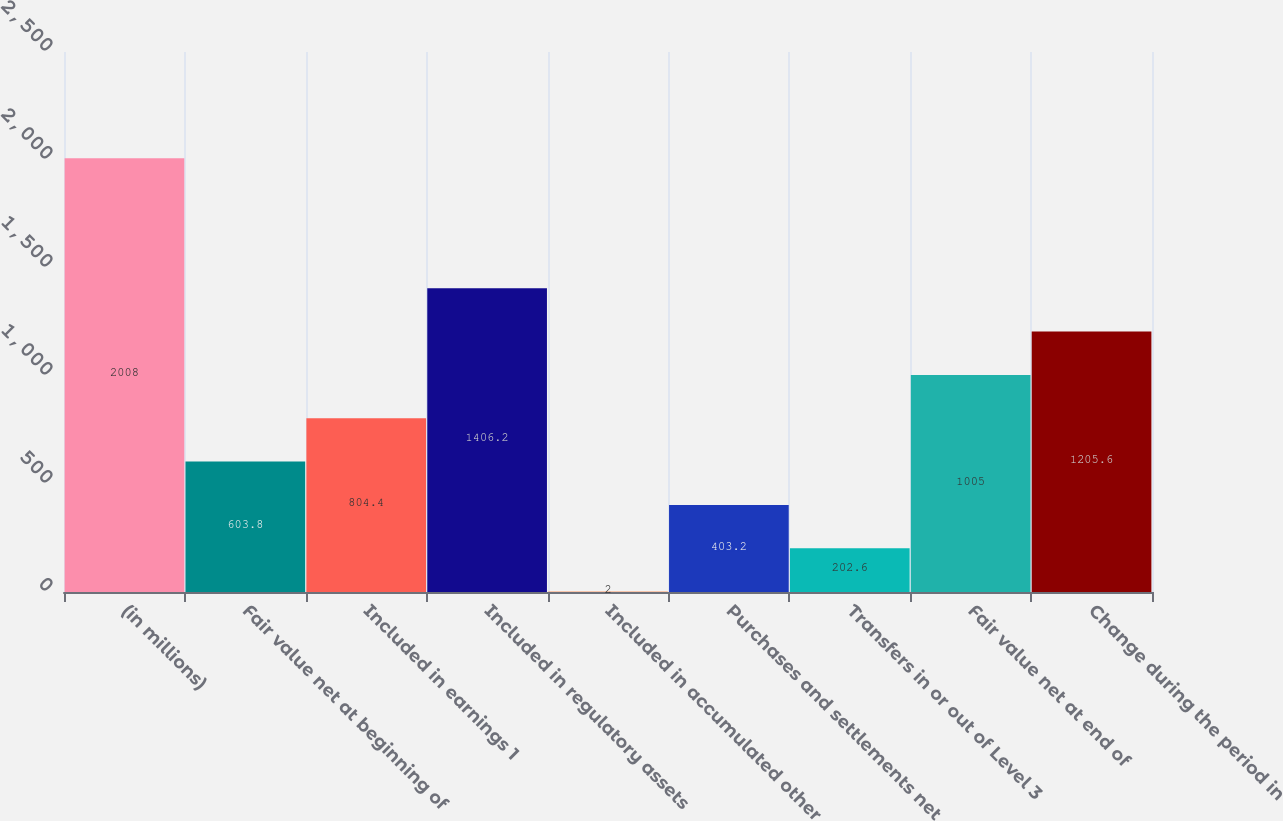<chart> <loc_0><loc_0><loc_500><loc_500><bar_chart><fcel>(in millions)<fcel>Fair value net at beginning of<fcel>Included in earnings 1<fcel>Included in regulatory assets<fcel>Included in accumulated other<fcel>Purchases and settlements net<fcel>Transfers in or out of Level 3<fcel>Fair value net at end of<fcel>Change during the period in<nl><fcel>2008<fcel>603.8<fcel>804.4<fcel>1406.2<fcel>2<fcel>403.2<fcel>202.6<fcel>1005<fcel>1205.6<nl></chart> 